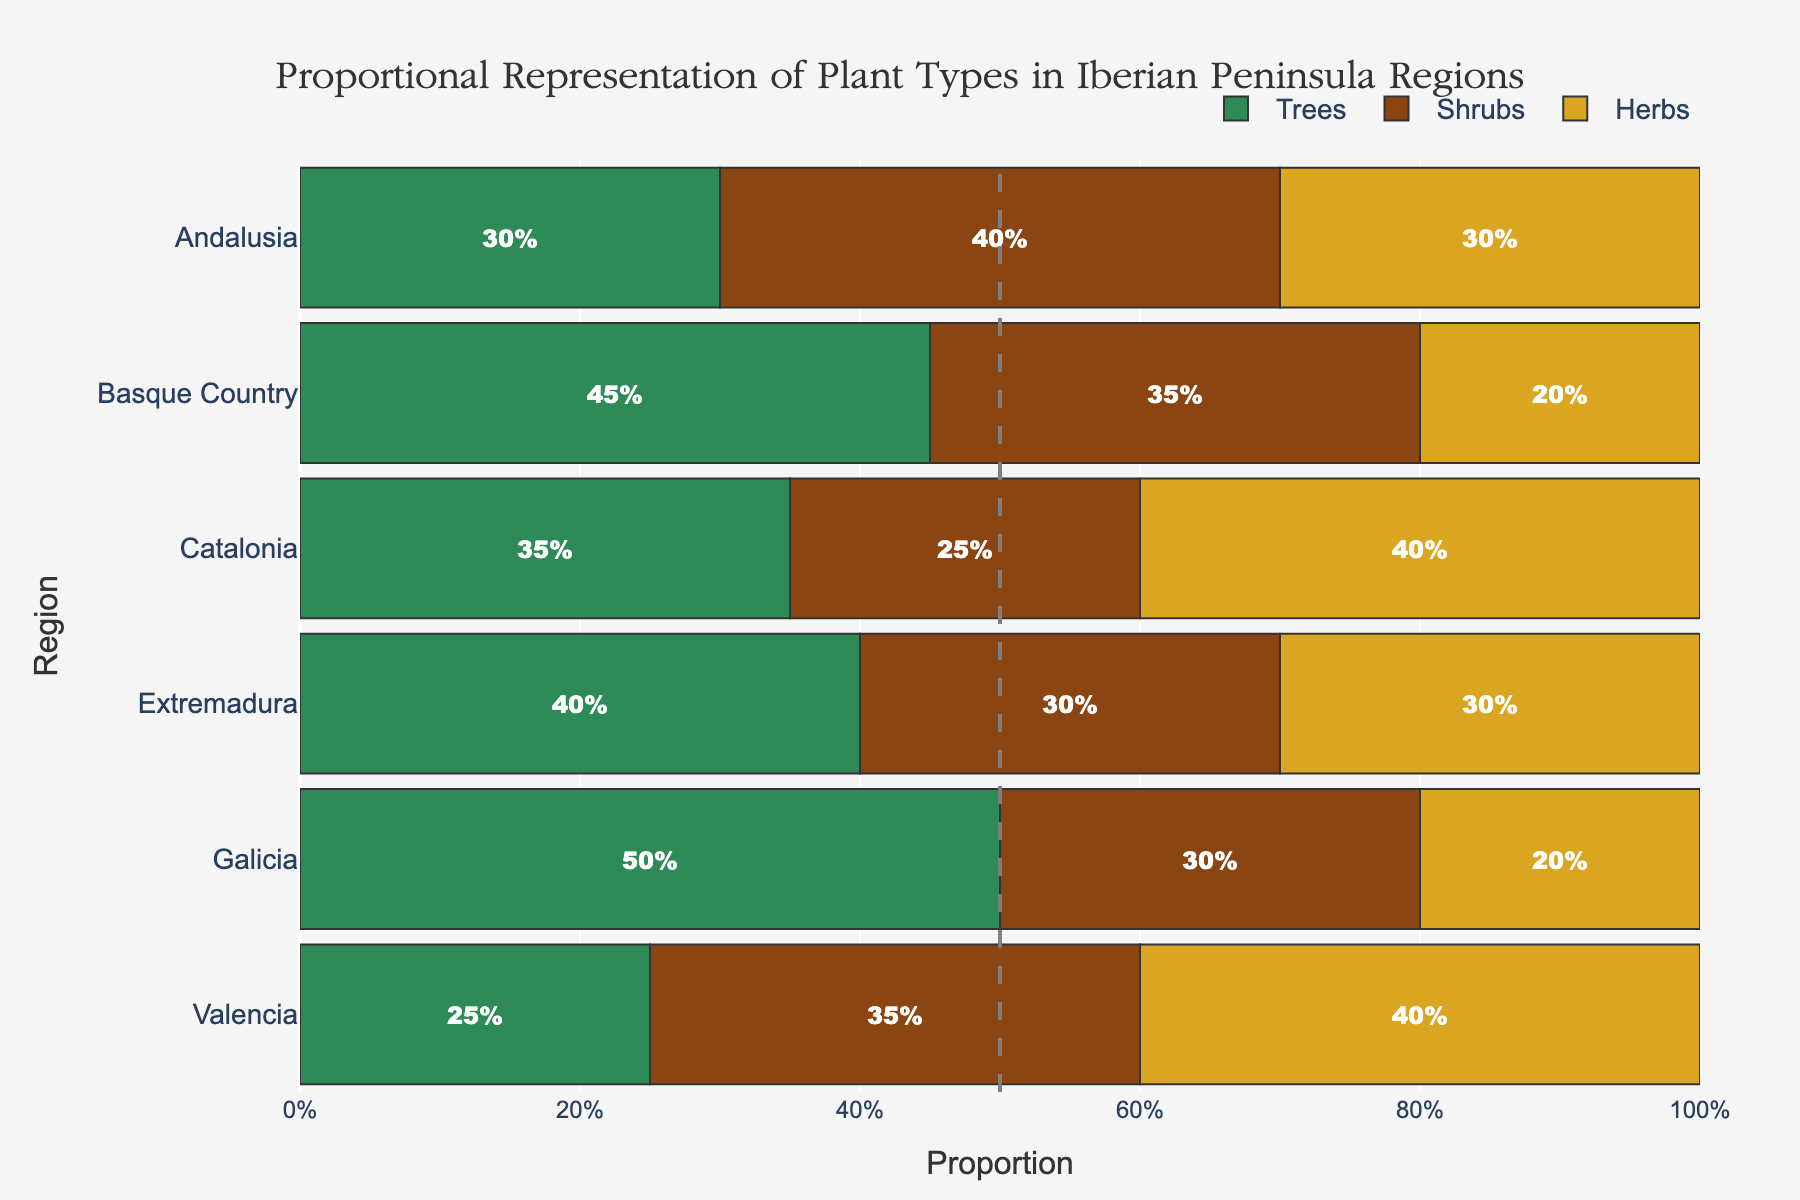Which region has the highest proportion of trees? The region with the highest proportion of trees is determined by looking at the length of the bars representing trees in each region. In the plot, Galicia and Basque Country have the longest green bars, representing trees.
Answer: Galicia Which region has the lowest proportion of herbs? The region with the lowest proportion of herbs can be identified by looking at which region has the shortest length for the yellow bars representing herbs. In this case, Galicia and Basque Country both have the shortest yellow bars for herbs.
Answer: Galicia and Basque Country How does the proportion of shrubs in Catalonia compare to that in Andalusia? By comparing the lengths of the brown bars for shrubs in Catalonia and Andalusia, we can see that Andalusia has a longer brown bar than Catalonia. This indicates that the proportion of shrubs in Andalusia (0.40) is higher than in Catalonia (0.25).
Answer: Andalusia has a higher proportion What is the sum of the proportions of trees and shrubs in Valencia? To find the sum, add the proportions of trees and shrubs in Valencia. From the data: Trees (0.25) + Shrubs (0.35) = 0.60.
Answer: 0.60 Which region has an equal proportion of herbs and trees? Identifying the regions where the lengths of green bars (trees) and yellow bars (herbs) are equal leads to checking Extremadura's proportions. Both trees and herbs in Extremadura are 0.30.
Answer: Extremadura Which plant type is the most represented in Catalonia? By comparing the length of the bars for each plant type in Catalonia, we find the yellow bar (representing herbs) is the longest. This indicates that herbs are the most represented plant type in Catalonia.
Answer: Herbs Is the proportion of trees in Basque Country greater than the proportion of trees in Extremadura? By comparing the length of the green bars for trees in Basque Country (0.45) and Extremadura (0.40), we see that Basque Country has a slightly longer green bar.
Answer: Yes What is the difference in the proportion of shrubs between Catalonia and Galicia? The difference in the proportion of shrubs between the two regions is obtained by subtracting the smaller proportion from the larger proportion. From the data: Shrubs in Catalonia (0.25) and Shrubs in Galicia (0.30). The difference is 0.30 - 0.25 = 0.05.
Answer: 0.05 Which region has the most balanced representation of all three plant types? A balanced representation implies that the proportions of trees, shrubs, and herbs are close to each other in a region. Comparing the lengths of the bars for all three plant types across regions, Andalusia shows the most balanced representation with trees (0.30), shrubs (0.40), and herbs (0.30).
Answer: Andalusia 